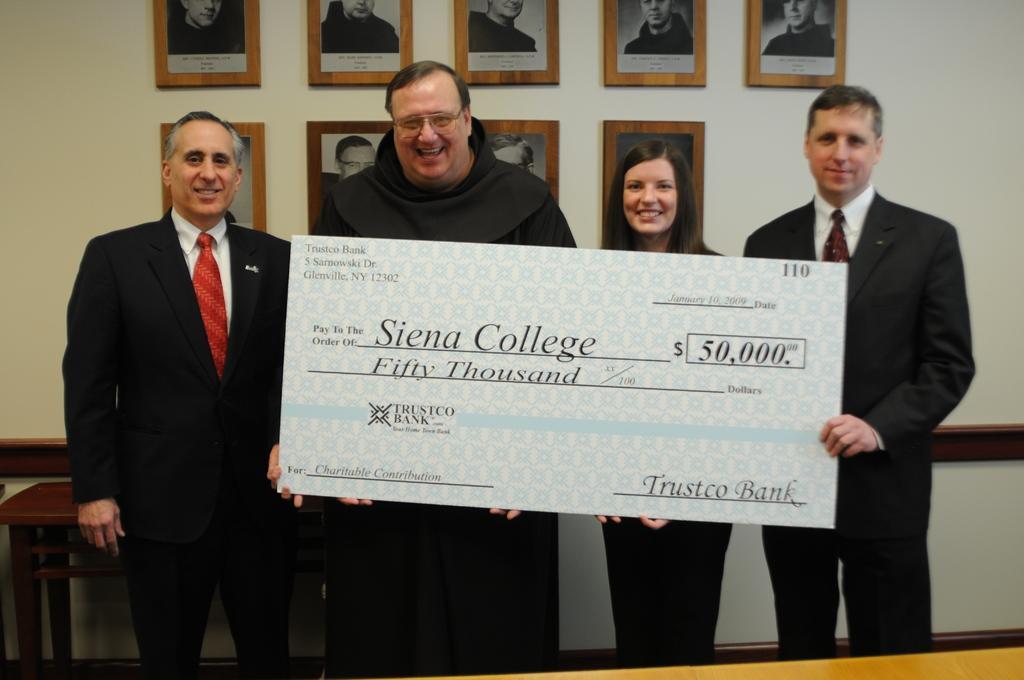In one or two sentences, can you explain what this image depicts? In this image we can see few persons and among them few persons are holding a big cheque in their hands. In the background we can see a table and frames on the wall. 